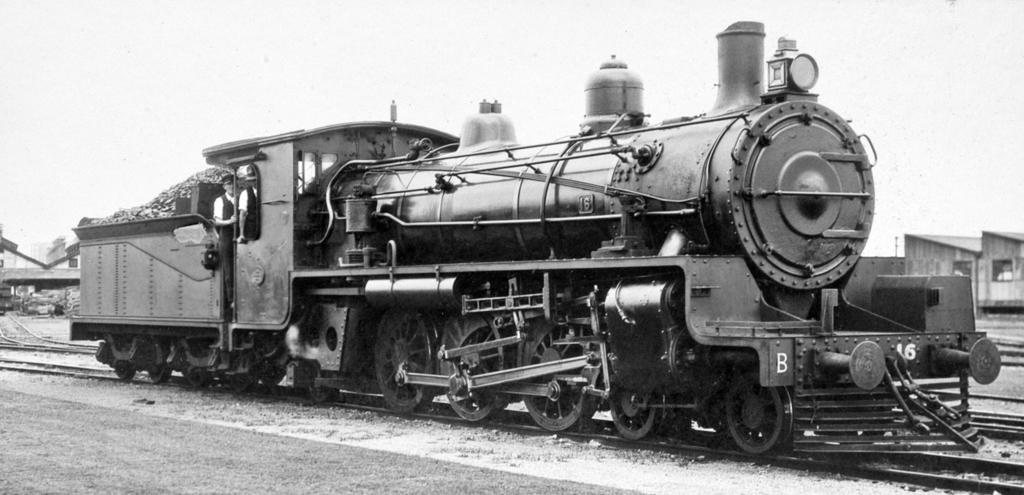What is the color scheme of the image? The image is black and white. What is the main subject of the image? There is a train engine in the image. Where is the train engine located? The train engine is on a railway track. Are there any people present in the image? Yes, there are two persons standing behind the train engine. What type of oatmeal is being served to the passengers in the image? There is no oatmeal or passengers present in the image; it features a black and white image of a train engine on a railway track with two persons standing behind it. 